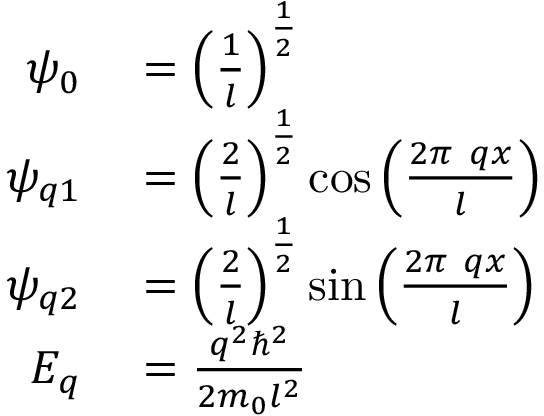<formula> <loc_0><loc_0><loc_500><loc_500>\begin{array} { r l } { \psi _ { 0 } } & = \left ( { \frac { 1 } { l } } \right ) ^ { \frac { 1 } { 2 } } } \\ { \psi _ { q 1 } } & = \left ( { \frac { 2 } { l } } \right ) ^ { \frac { 1 } { 2 } } \cos { \left ( { \frac { 2 \pi \ q x } { l } } \right ) } } \\ { \psi _ { q 2 } } & = \left ( { \frac { 2 } { l } } \right ) ^ { \frac { 1 } { 2 } } \sin { \left ( { \frac { 2 \pi \ q x } { l } } \right ) } } \\ { E _ { q } } & = { \frac { q ^ { 2 } \hbar { ^ } { 2 } } { 2 m _ { 0 } l ^ { 2 } } } } \end{array}</formula> 